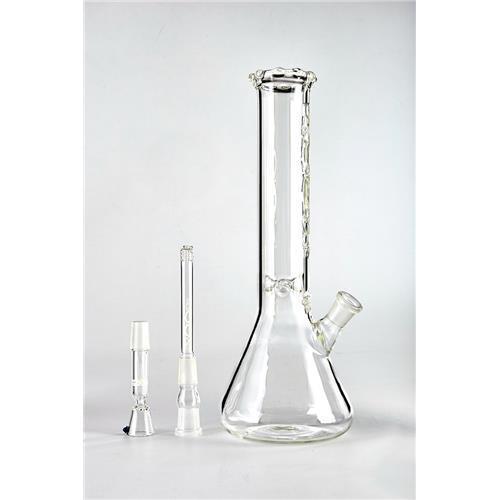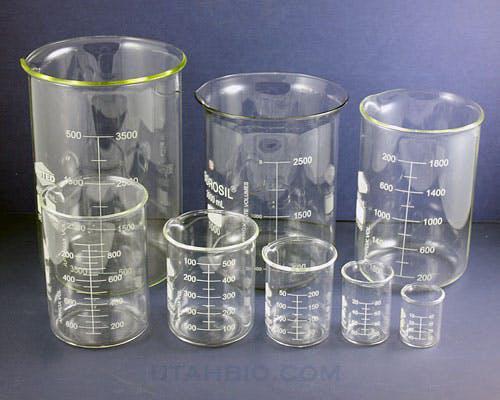The first image is the image on the left, the second image is the image on the right. Evaluate the accuracy of this statement regarding the images: "Each image contains colored liquid in a container, and at least one image includes a beaker without a handle containing red liquid.". Is it true? Answer yes or no. No. The first image is the image on the left, the second image is the image on the right. Analyze the images presented: Is the assertion "In at least one image there is one clear beaker bong with glass mouth peice." valid? Answer yes or no. Yes. 